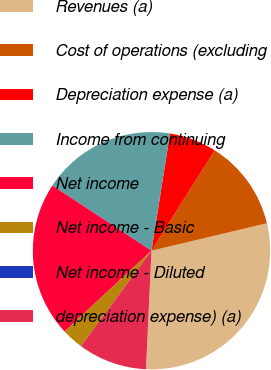Convert chart. <chart><loc_0><loc_0><loc_500><loc_500><pie_chart><fcel>Revenues (a)<fcel>Cost of operations (excluding<fcel>Depreciation expense (a)<fcel>Income from continuing<fcel>Net income<fcel>Net income - Basic<fcel>Net income - Diluted<fcel>depreciation expense) (a)<nl><fcel>29.45%<fcel>12.34%<fcel>6.45%<fcel>18.23%<fcel>21.18%<fcel>2.94%<fcel>0.0%<fcel>9.4%<nl></chart> 